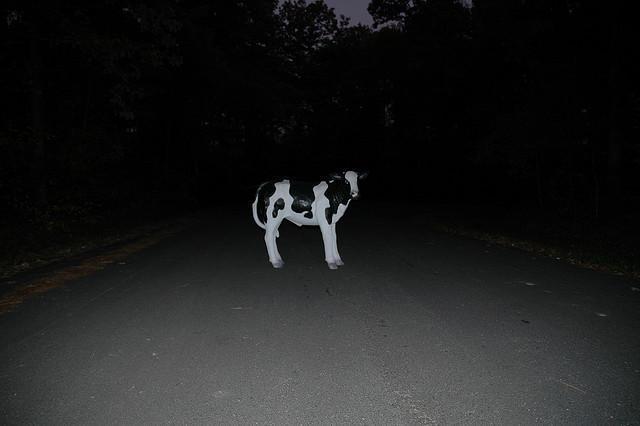How many animals are shown?
Give a very brief answer. 1. How many cows are there?
Give a very brief answer. 1. 